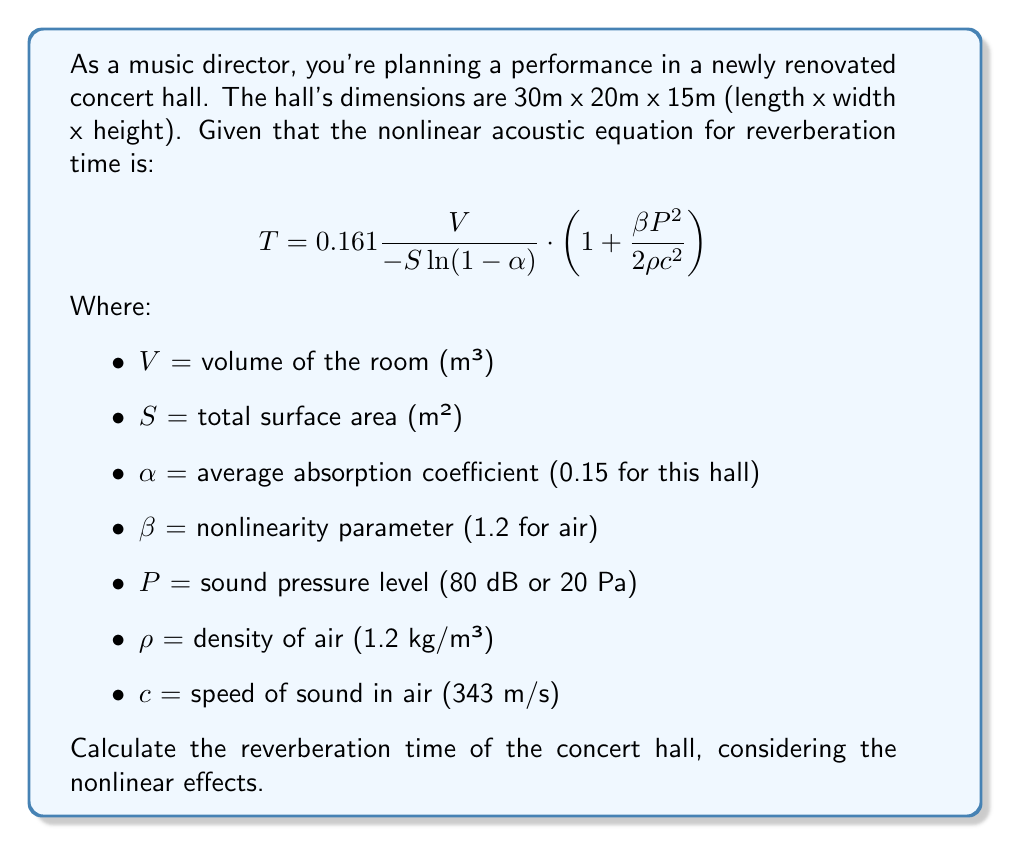What is the answer to this math problem? Let's approach this step-by-step:

1) First, calculate the volume of the room:
   $V = 30 \text{ m} \times 20 \text{ m} \times 15 \text{ m} = 9000 \text{ m}^3$

2) Calculate the total surface area:
   $S = 2(30 \times 20 + 30 \times 15 + 20 \times 15) = 2100 \text{ m}^2$

3) Now, let's substitute the known values into the equation:

   $$T = 0.161 \frac{9000}{-2100 \ln(1-0.15)} \cdot \left(1 + \frac{1.2 \cdot 20^2}{2 \cdot 1.2 \cdot 343^2}\right)$$

4) Simplify the denominator in the first fraction:
   $-2100 \ln(1-0.15) = -2100 \cdot (-0.1625) = 341.25$

5) Simplify the fraction in the parentheses:
   $\frac{1.2 \cdot 20^2}{2 \cdot 1.2 \cdot 343^2} = \frac{480}{282812.4} \approx 0.0017$

6) Now our equation looks like:

   $$T = 0.161 \frac{9000}{341.25} \cdot (1 + 0.0017)$$

7) Simplify:
   $$T = 0.161 \cdot 26.37 \cdot 1.0017 \approx 4.25 \text{ seconds}$$
Answer: 4.25 seconds 